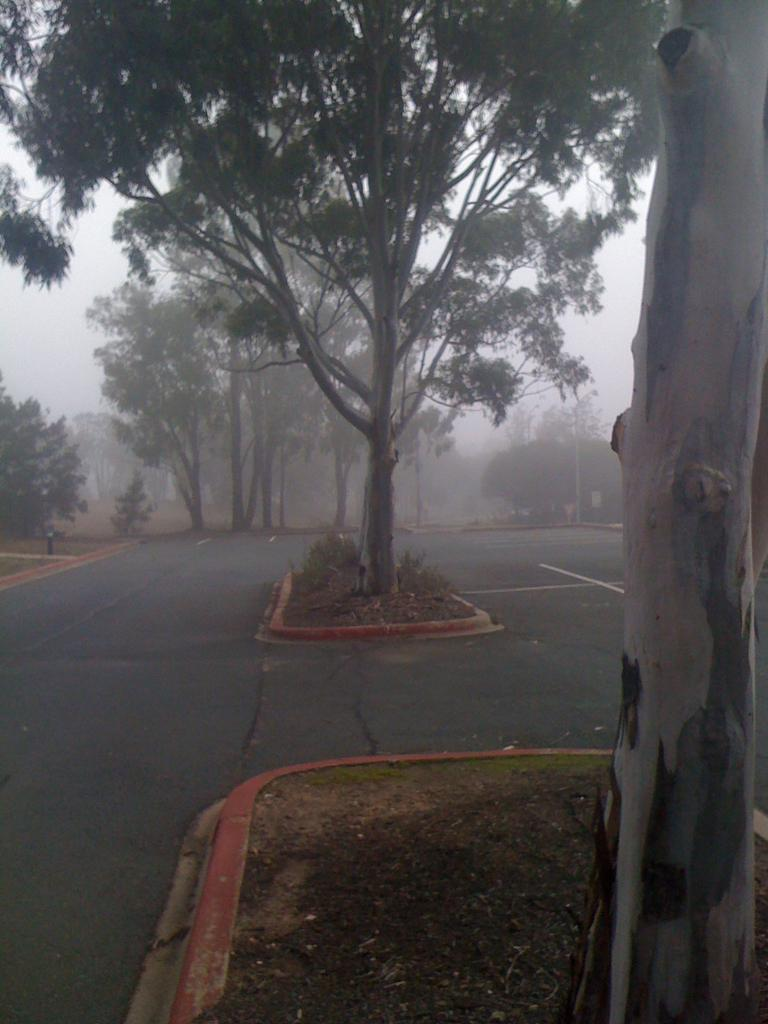What is the main feature of the image? There is a road in the image. What can be seen alongside the road? There are trees and grass along the road. How would you describe the climate in the image? The climate in the image is filled with fog. Where is the throne located in the image? There is no throne present in the image. What type of letters can be seen on the trees in the image? There are no letters visible on the trees in the image. 